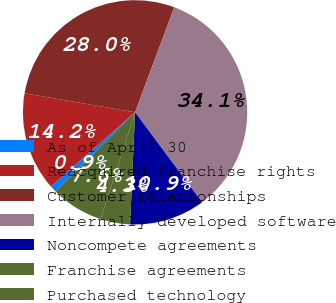<chart> <loc_0><loc_0><loc_500><loc_500><pie_chart><fcel>As of April 30<fcel>Reacquired franchise rights<fcel>Customer relationships<fcel>Internally-developed software<fcel>Noncompete agreements<fcel>Franchise agreements<fcel>Purchased technology<nl><fcel>0.95%<fcel>14.22%<fcel>27.97%<fcel>34.12%<fcel>10.9%<fcel>4.26%<fcel>7.58%<nl></chart> 